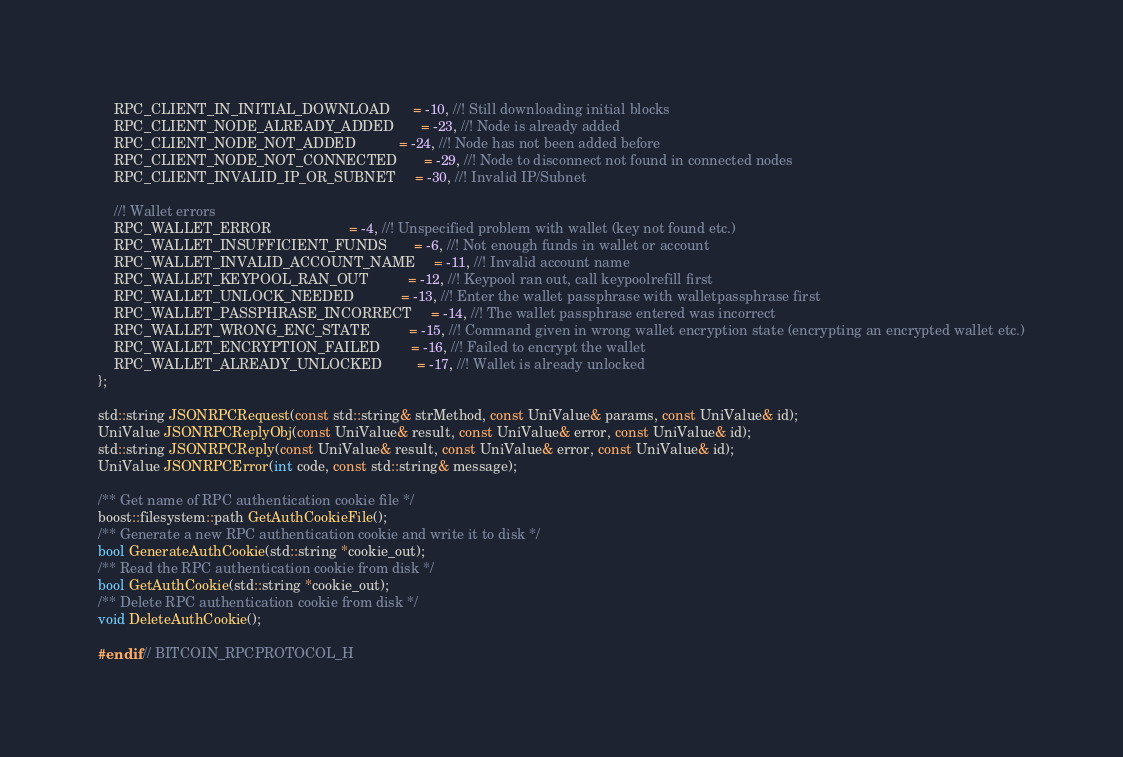<code> <loc_0><loc_0><loc_500><loc_500><_C_>    RPC_CLIENT_IN_INITIAL_DOWNLOAD      = -10, //! Still downloading initial blocks
    RPC_CLIENT_NODE_ALREADY_ADDED       = -23, //! Node is already added
    RPC_CLIENT_NODE_NOT_ADDED           = -24, //! Node has not been added before
    RPC_CLIENT_NODE_NOT_CONNECTED       = -29, //! Node to disconnect not found in connected nodes
    RPC_CLIENT_INVALID_IP_OR_SUBNET     = -30, //! Invalid IP/Subnet

    //! Wallet errors
    RPC_WALLET_ERROR                    = -4, //! Unspecified problem with wallet (key not found etc.)
    RPC_WALLET_INSUFFICIENT_FUNDS       = -6, //! Not enough funds in wallet or account
    RPC_WALLET_INVALID_ACCOUNT_NAME     = -11, //! Invalid account name
    RPC_WALLET_KEYPOOL_RAN_OUT          = -12, //! Keypool ran out, call keypoolrefill first
    RPC_WALLET_UNLOCK_NEEDED            = -13, //! Enter the wallet passphrase with walletpassphrase first
    RPC_WALLET_PASSPHRASE_INCORRECT     = -14, //! The wallet passphrase entered was incorrect
    RPC_WALLET_WRONG_ENC_STATE          = -15, //! Command given in wrong wallet encryption state (encrypting an encrypted wallet etc.)
    RPC_WALLET_ENCRYPTION_FAILED        = -16, //! Failed to encrypt the wallet
    RPC_WALLET_ALREADY_UNLOCKED         = -17, //! Wallet is already unlocked
};

std::string JSONRPCRequest(const std::string& strMethod, const UniValue& params, const UniValue& id);
UniValue JSONRPCReplyObj(const UniValue& result, const UniValue& error, const UniValue& id);
std::string JSONRPCReply(const UniValue& result, const UniValue& error, const UniValue& id);
UniValue JSONRPCError(int code, const std::string& message);

/** Get name of RPC authentication cookie file */
boost::filesystem::path GetAuthCookieFile();
/** Generate a new RPC authentication cookie and write it to disk */
bool GenerateAuthCookie(std::string *cookie_out);
/** Read the RPC authentication cookie from disk */
bool GetAuthCookie(std::string *cookie_out);
/** Delete RPC authentication cookie from disk */
void DeleteAuthCookie();

#endif // BITCOIN_RPCPROTOCOL_H
</code> 